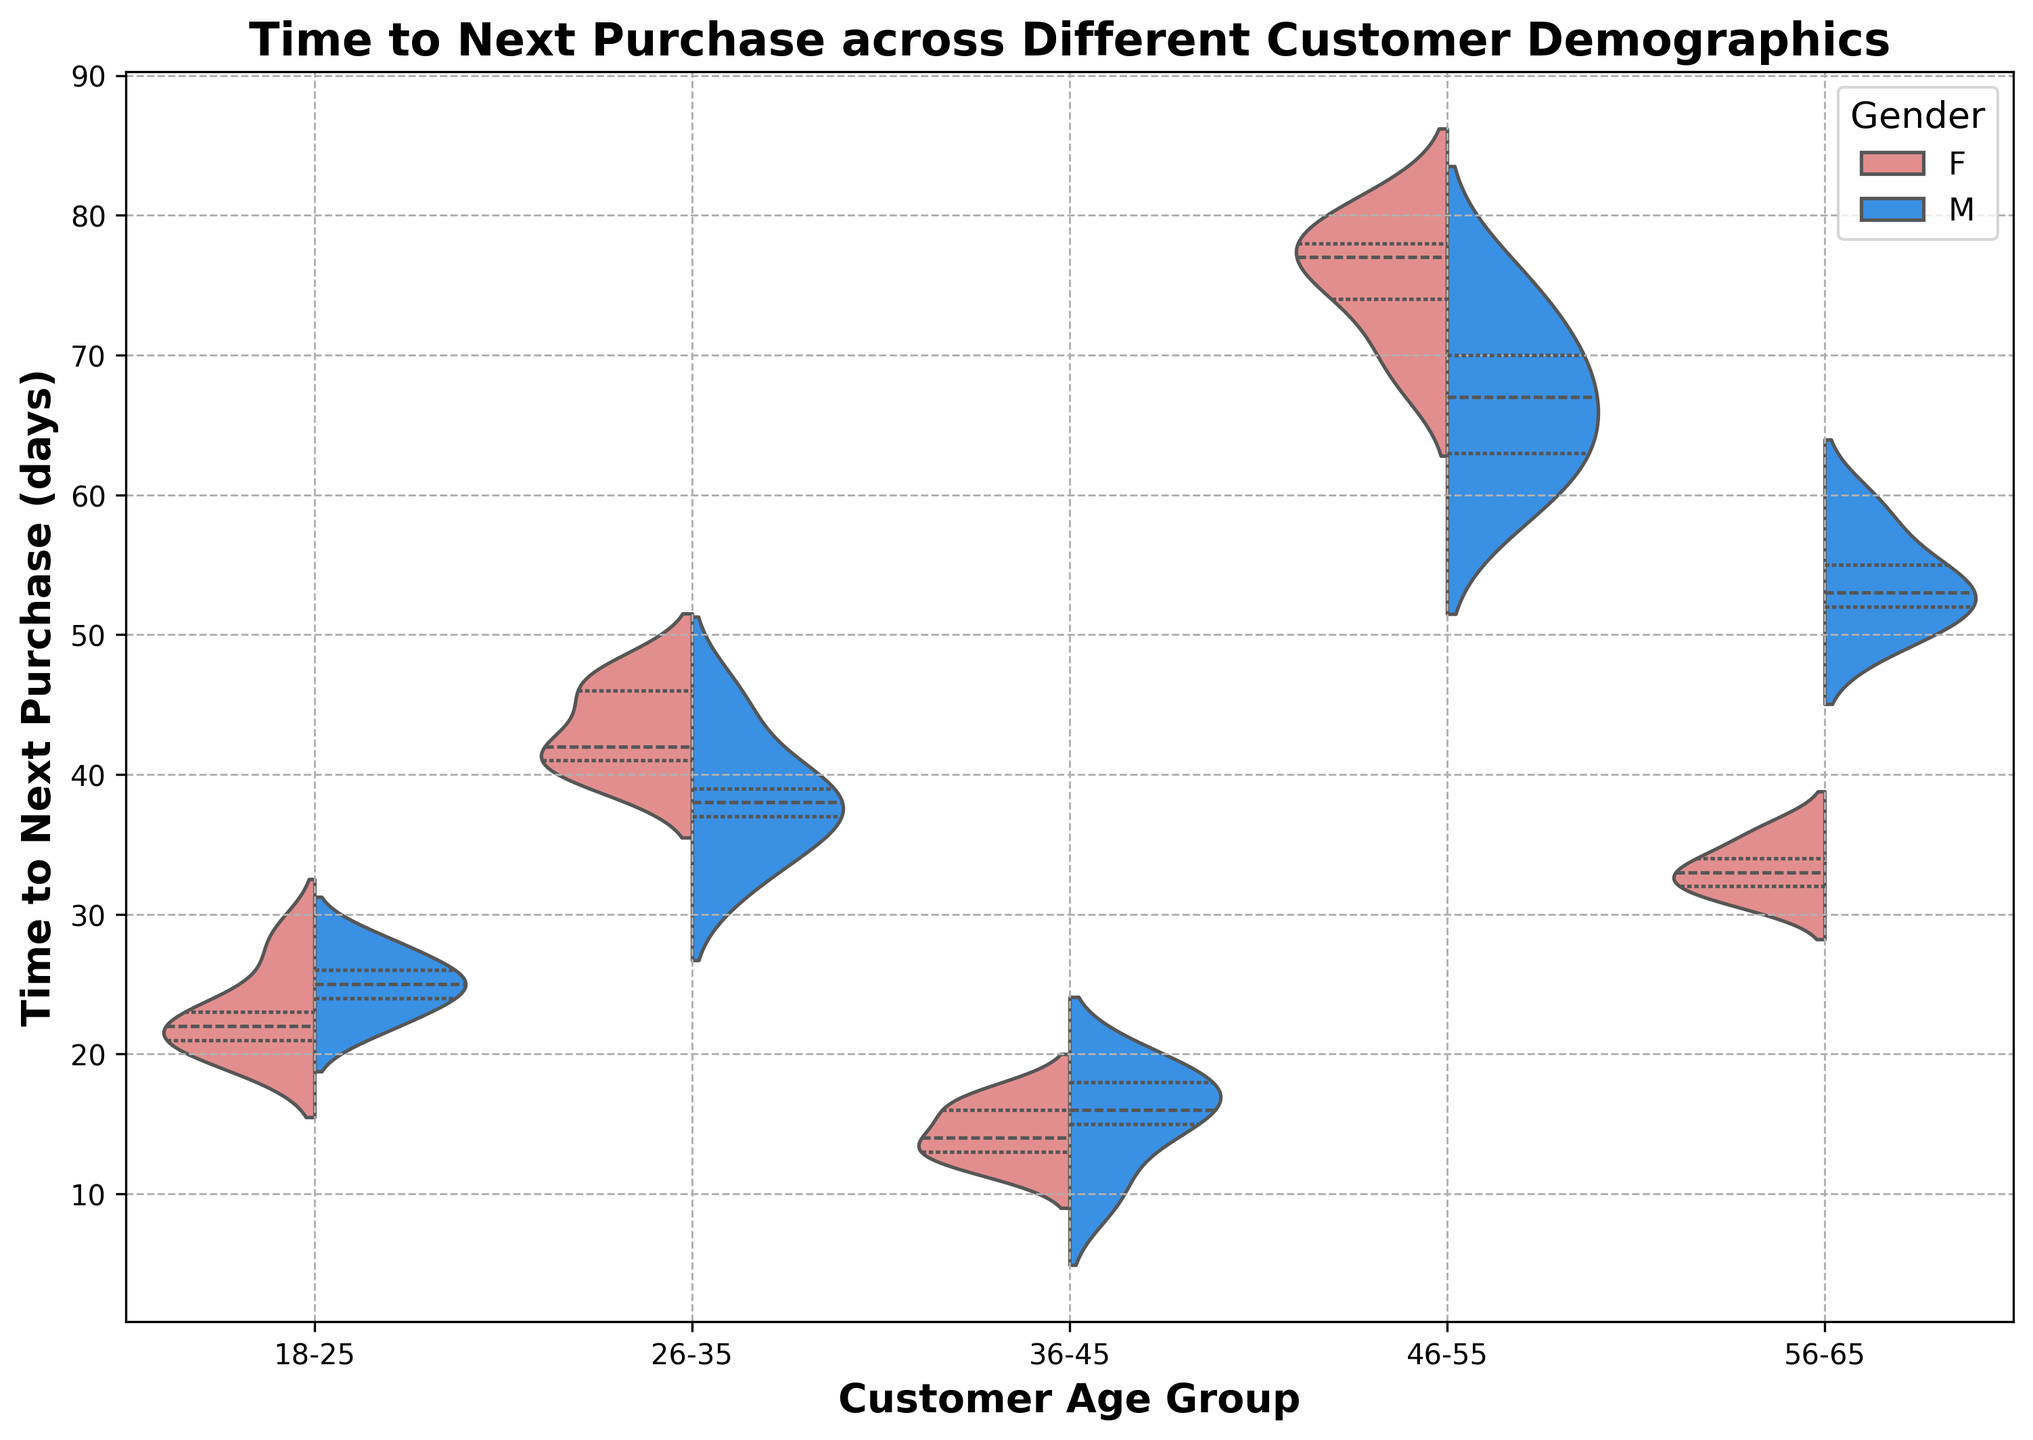Which age group has the shortest typical time to next purchase for males? By examining the blue (male) segments of the violins, the group with the shortest time to next purchase is indicated by the lowest median line. Look for the group where the blue segment's quartile is shortest on the y-axis.
Answer: 36-45 Which gender in the 46-55 age group has a greater spread in time to next purchase? Compare the heights (spread) of the red (female) and blue (male) portions within the 46-55 age group violin plot. The gender with the more extensive spread along the y-axis will have a more significant range of values.
Answer: Female Is the median time to next purchase generally higher for males or females in the 56-65 age group? Locate the median lines within the red (female) and blue (male) sections for the 56-65 age group and determine which is positioned higher on the y-axis. The higher line indicates a higher median.
Answer: Male Which age group shows the most balanced time to next purchase between genders? Look for the age group where the overlapping sections of the male (blue) and female (red) violins are most symmetrical and similar in spread and median lines.
Answer: 18-25 What is the approximate range of time to next purchase for females in the 36-45 age group? Identify the red (female) violin for the 36-45 age group and observe the range from the bottom to the top of the violin plot. This indicates the approximate range.
Answer: 10-17 days In the 26-35 age group, do males or females have a higher interquartile range (IQR) for time to next purchase? Compare the widths of the middle 50% (interquartile range) sections in the red (female) and blue (male) sections of the violin plot for the 26-35 age group. The section with the larger spread between the first and third quartile lines has the higher IQR.
Answer: Female How does the average female’s time to next purchase in the 46-55 age group compare to the same metric in the 18-25 age group? The average time can be visually estimated by examining the spread and central tendency of the red (female) sections in both age groups. Determine whether the central locations of the female segments of these age groups suggest higher or lower values.
Answer: Higher in 46-55 Which gender in the 18-25 age group has a lower median time to next purchase? Identify the median lines within both the red (female) and blue (male) sections for the 18-25 age group and see which one is positioned lower on the y-axis.
Answer: Female 